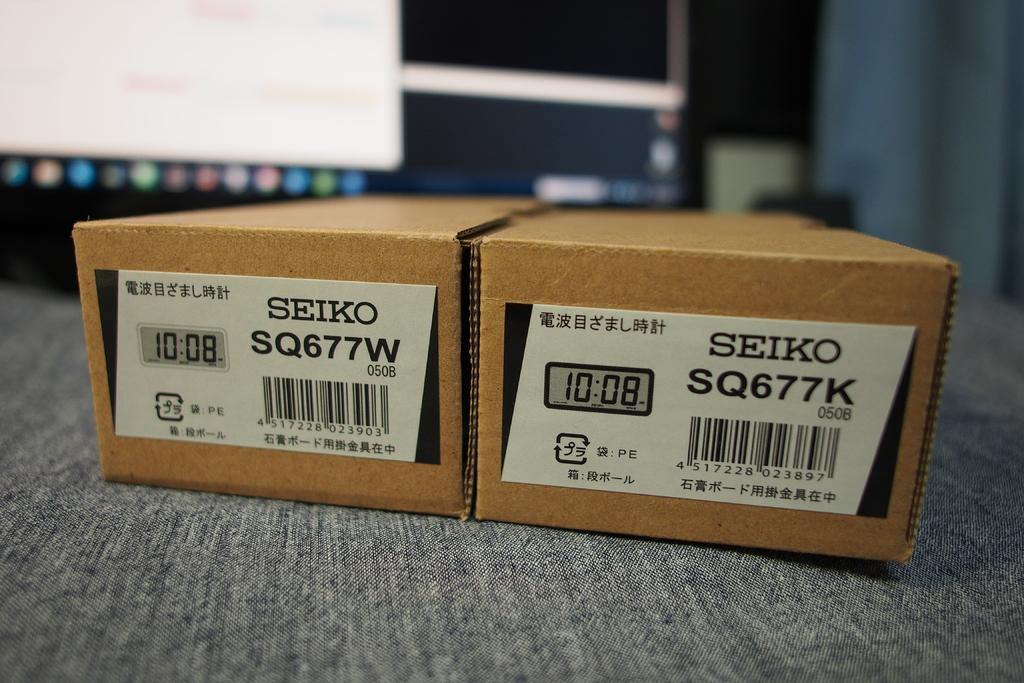<image>
Relay a brief, clear account of the picture shown. two boxes played in front of the computer screen which has a writings of SEIKO SQ677W and SQ677K 